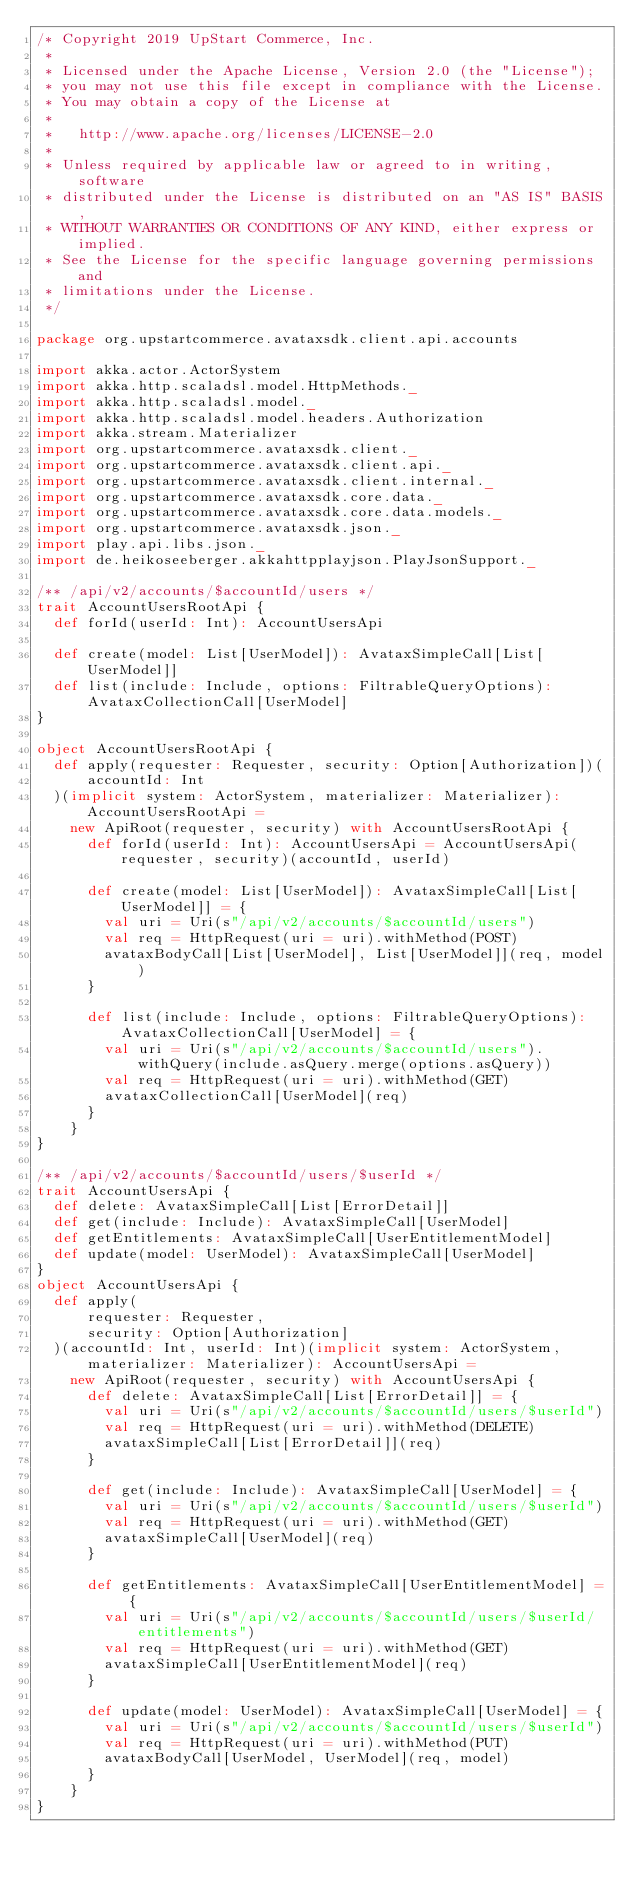Convert code to text. <code><loc_0><loc_0><loc_500><loc_500><_Scala_>/* Copyright 2019 UpStart Commerce, Inc.
 *
 * Licensed under the Apache License, Version 2.0 (the "License");
 * you may not use this file except in compliance with the License.
 * You may obtain a copy of the License at
 *
 *   http://www.apache.org/licenses/LICENSE-2.0
 *
 * Unless required by applicable law or agreed to in writing, software
 * distributed under the License is distributed on an "AS IS" BASIS,
 * WITHOUT WARRANTIES OR CONDITIONS OF ANY KIND, either express or implied.
 * See the License for the specific language governing permissions and
 * limitations under the License.
 */

package org.upstartcommerce.avataxsdk.client.api.accounts

import akka.actor.ActorSystem
import akka.http.scaladsl.model.HttpMethods._
import akka.http.scaladsl.model._
import akka.http.scaladsl.model.headers.Authorization
import akka.stream.Materializer
import org.upstartcommerce.avataxsdk.client._
import org.upstartcommerce.avataxsdk.client.api._
import org.upstartcommerce.avataxsdk.client.internal._
import org.upstartcommerce.avataxsdk.core.data._
import org.upstartcommerce.avataxsdk.core.data.models._
import org.upstartcommerce.avataxsdk.json._
import play.api.libs.json._
import de.heikoseeberger.akkahttpplayjson.PlayJsonSupport._

/** /api/v2/accounts/$accountId/users */
trait AccountUsersRootApi {
  def forId(userId: Int): AccountUsersApi

  def create(model: List[UserModel]): AvataxSimpleCall[List[UserModel]]
  def list(include: Include, options: FiltrableQueryOptions): AvataxCollectionCall[UserModel]
}

object AccountUsersRootApi {
  def apply(requester: Requester, security: Option[Authorization])(
      accountId: Int
  )(implicit system: ActorSystem, materializer: Materializer): AccountUsersRootApi =
    new ApiRoot(requester, security) with AccountUsersRootApi {
      def forId(userId: Int): AccountUsersApi = AccountUsersApi(requester, security)(accountId, userId)

      def create(model: List[UserModel]): AvataxSimpleCall[List[UserModel]] = {
        val uri = Uri(s"/api/v2/accounts/$accountId/users")
        val req = HttpRequest(uri = uri).withMethod(POST)
        avataxBodyCall[List[UserModel], List[UserModel]](req, model)
      }

      def list(include: Include, options: FiltrableQueryOptions): AvataxCollectionCall[UserModel] = {
        val uri = Uri(s"/api/v2/accounts/$accountId/users").withQuery(include.asQuery.merge(options.asQuery))
        val req = HttpRequest(uri = uri).withMethod(GET)
        avataxCollectionCall[UserModel](req)
      }
    }
}

/** /api/v2/accounts/$accountId/users/$userId */
trait AccountUsersApi {
  def delete: AvataxSimpleCall[List[ErrorDetail]]
  def get(include: Include): AvataxSimpleCall[UserModel]
  def getEntitlements: AvataxSimpleCall[UserEntitlementModel]
  def update(model: UserModel): AvataxSimpleCall[UserModel]
}
object AccountUsersApi {
  def apply(
      requester: Requester,
      security: Option[Authorization]
  )(accountId: Int, userId: Int)(implicit system: ActorSystem, materializer: Materializer): AccountUsersApi =
    new ApiRoot(requester, security) with AccountUsersApi {
      def delete: AvataxSimpleCall[List[ErrorDetail]] = {
        val uri = Uri(s"/api/v2/accounts/$accountId/users/$userId")
        val req = HttpRequest(uri = uri).withMethod(DELETE)
        avataxSimpleCall[List[ErrorDetail]](req)
      }

      def get(include: Include): AvataxSimpleCall[UserModel] = {
        val uri = Uri(s"/api/v2/accounts/$accountId/users/$userId")
        val req = HttpRequest(uri = uri).withMethod(GET)
        avataxSimpleCall[UserModel](req)
      }

      def getEntitlements: AvataxSimpleCall[UserEntitlementModel] = {
        val uri = Uri(s"/api/v2/accounts/$accountId/users/$userId/entitlements")
        val req = HttpRequest(uri = uri).withMethod(GET)
        avataxSimpleCall[UserEntitlementModel](req)
      }

      def update(model: UserModel): AvataxSimpleCall[UserModel] = {
        val uri = Uri(s"/api/v2/accounts/$accountId/users/$userId")
        val req = HttpRequest(uri = uri).withMethod(PUT)
        avataxBodyCall[UserModel, UserModel](req, model)
      }
    }
}
</code> 